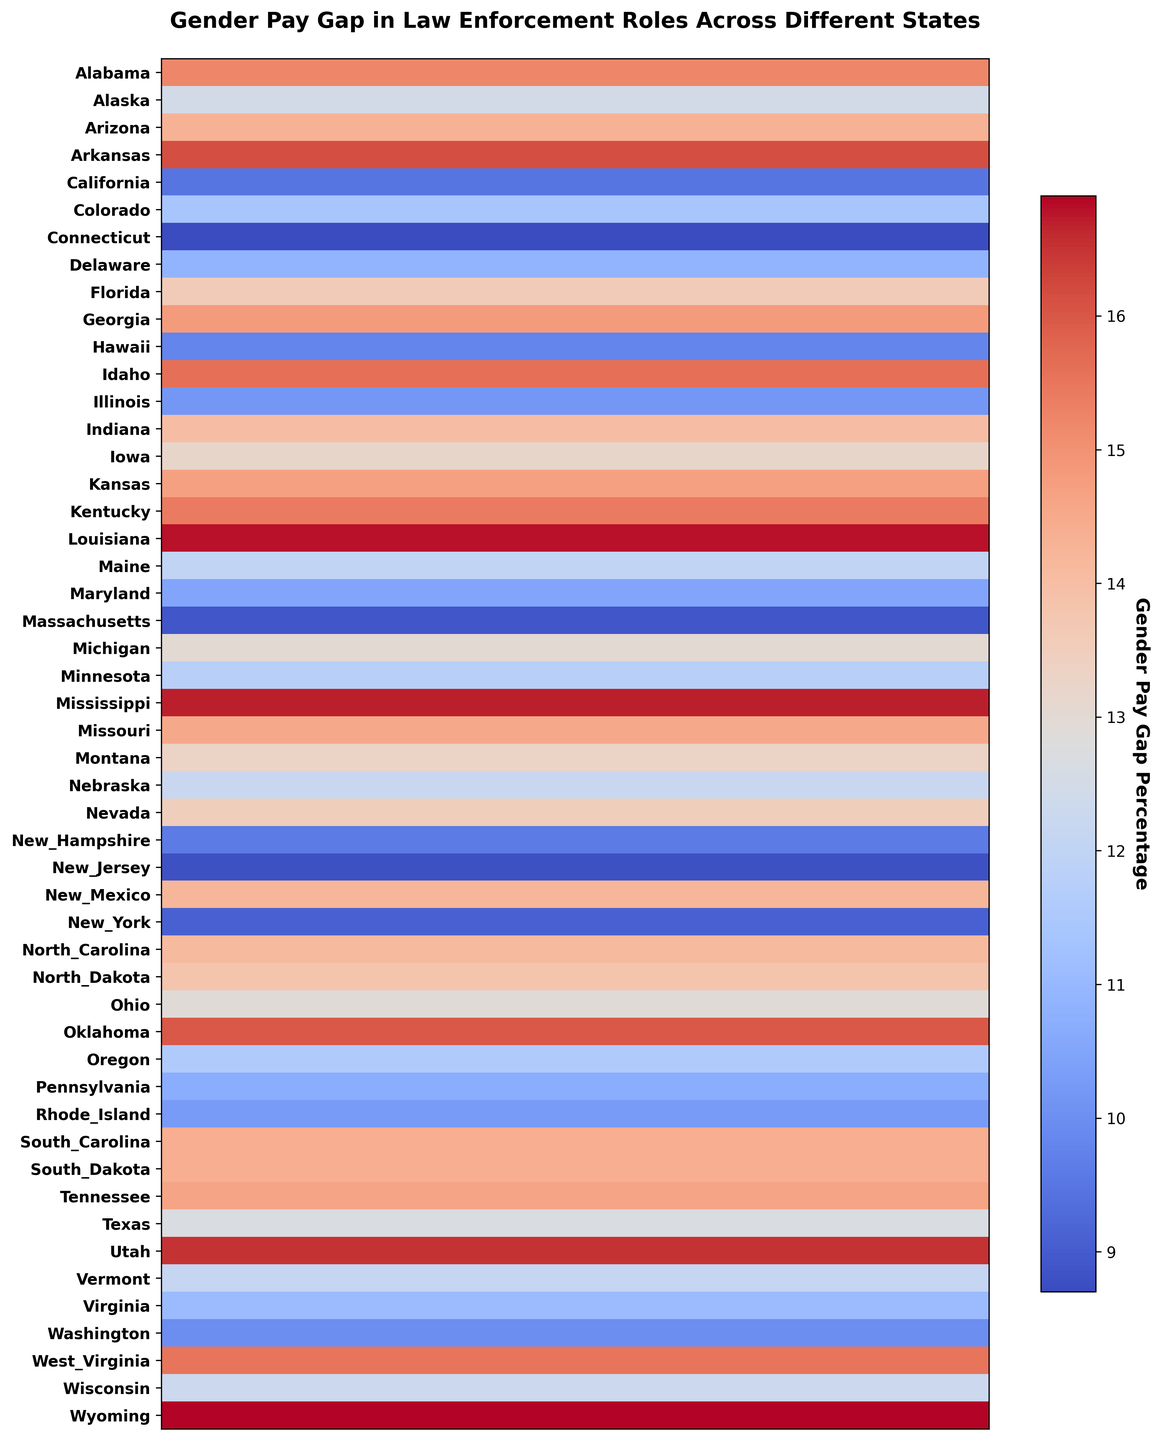What's the state with the highest gender pay gap percentage? The color corresponding to the highest gender pay gap percentage should be the darkest or most intense hue. Checking the darkest hue, Wyoming has the highest gap at 16.9%.
Answer: Wyoming Which state has the smallest gender pay gap percentage? The color corresponding to the smallest gender pay gap percentage should be the lightest hue. Checking the lightest hue, Connecticut has the smallest gap at 8.7%.
Answer: Connecticut What's the difference in gender pay gap percentage between Alabama and California? Alabama has a gap of 15.2%, and California has a gap of 9.5%. The difference is calculated as 15.2% - 9.5% = 5.7%.
Answer: 5.7% Which states have gender pay gap percentages less than 10%? By looking at lighter colored states or checking the numerical labels, the states with a gender pay gap less than 10% are California, Connecticut, Hawaii, Massachusetts, New Hampshire, New Jersey, and New York.
Answer: California, Connecticut, Hawaii, Massachusetts, New Hampshire, New Jersey, New York Is the gender pay gap in Alaska closer to that of Texas or Florida? Alaska has a pay gap of 12.5%. Comparing with Texas (12.7%) and Florida (13.6%), Alaska's gap is closer to Texas at 12.7%.
Answer: Texas What is the average gender pay gap percentage for states starting with 'N'? States starting with 'N' are Nebraska (12.2%), Nevada (13.5%), New Hampshire (9.6%), New Jersey (8.8%), New Mexico (14.2%), New York (9.1%), North Carolina (14.1%), and North Dakota (13.8%). Adding these gives: 12.2 + 13.5 + 9.6 + 8.8 + 14.2 + 9.1 + 14.1 + 13.8 = 95.3. Dividing by 8 states: 95.3/8 ≈ 11.9%.
Answer: 11.9% Which nearby states show the greatest contrast in gender pay gap percentages? Comparing neighboring states visually, Louisiana (16.8%) and Arkansas (16.1%) with Georgia (14.8%) and Florida (13.6%) show higher differences, but Wyoming (16.9%) and Colorado (11.4%) show an even greater contrast. The greatest contrast appears between Utah (16.5%) and Colorado (11.4%), a difference of 5.1%.
Answer: Utah and Colorado Which region of the United States generally shows higher gender pay gaps? By visually dividing the map into regions (Northeast, South, Midwest, West), the southern states show generally higher and darker hues indicating higher gender pay gaps.
Answer: South 